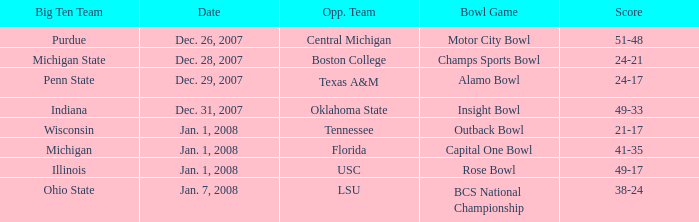Who was the opposing team in the game with a score of 21-17? Tennessee. Can you give me this table as a dict? {'header': ['Big Ten Team', 'Date', 'Opp. Team', 'Bowl Game', 'Score'], 'rows': [['Purdue', 'Dec. 26, 2007', 'Central Michigan', 'Motor City Bowl', '51-48'], ['Michigan State', 'Dec. 28, 2007', 'Boston College', 'Champs Sports Bowl', '24-21'], ['Penn State', 'Dec. 29, 2007', 'Texas A&M', 'Alamo Bowl', '24-17'], ['Indiana', 'Dec. 31, 2007', 'Oklahoma State', 'Insight Bowl', '49-33'], ['Wisconsin', 'Jan. 1, 2008', 'Tennessee', 'Outback Bowl', '21-17'], ['Michigan', 'Jan. 1, 2008', 'Florida', 'Capital One Bowl', '41-35'], ['Illinois', 'Jan. 1, 2008', 'USC', 'Rose Bowl', '49-17'], ['Ohio State', 'Jan. 7, 2008', 'LSU', 'BCS National Championship', '38-24']]} 